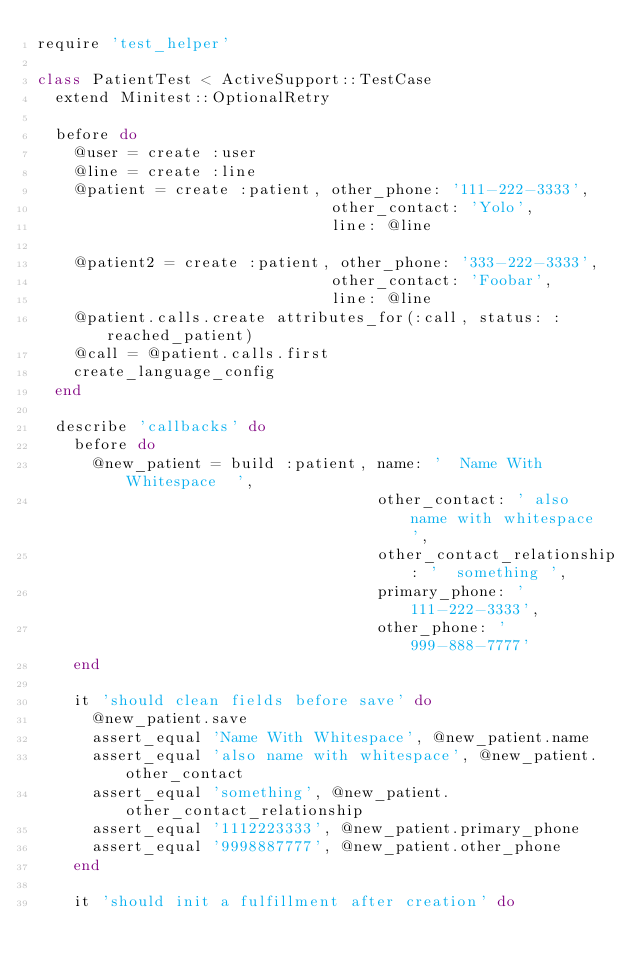<code> <loc_0><loc_0><loc_500><loc_500><_Ruby_>require 'test_helper'

class PatientTest < ActiveSupport::TestCase
  extend Minitest::OptionalRetry

  before do
    @user = create :user
    @line = create :line
    @patient = create :patient, other_phone: '111-222-3333',
                                other_contact: 'Yolo',
                                line: @line

    @patient2 = create :patient, other_phone: '333-222-3333',
                                other_contact: 'Foobar',
                                line: @line
    @patient.calls.create attributes_for(:call, status: :reached_patient)
    @call = @patient.calls.first
    create_language_config
  end

  describe 'callbacks' do
    before do
      @new_patient = build :patient, name: '  Name With Whitespace  ',
                                     other_contact: ' also name with whitespace ',
                                     other_contact_relationship: '  something ',
                                     primary_phone: '111-222-3333',
                                     other_phone: '999-888-7777'
    end

    it 'should clean fields before save' do
      @new_patient.save
      assert_equal 'Name With Whitespace', @new_patient.name
      assert_equal 'also name with whitespace', @new_patient.other_contact
      assert_equal 'something', @new_patient.other_contact_relationship
      assert_equal '1112223333', @new_patient.primary_phone
      assert_equal '9998887777', @new_patient.other_phone
    end

    it 'should init a fulfillment after creation' do</code> 